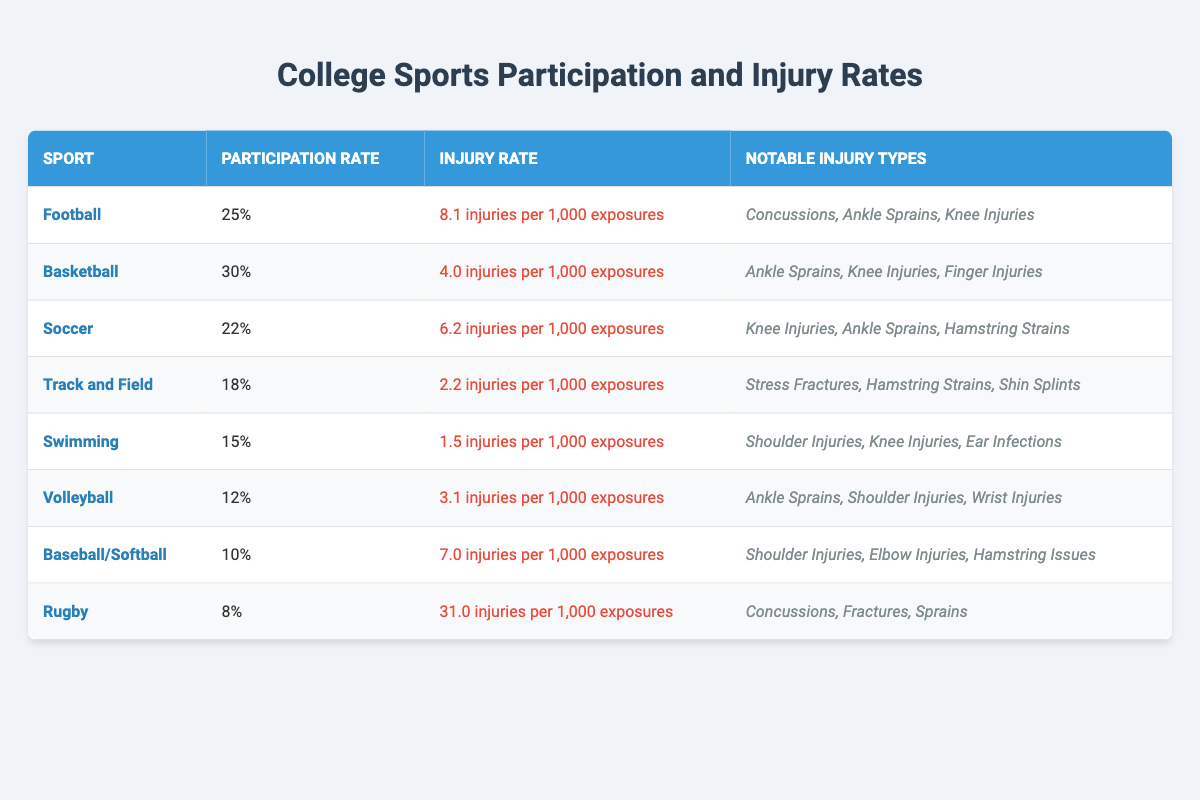What is the participation rate for Soccer? The table lists the participation rate for Soccer as 22%.
Answer: 22% Which sport has the highest injury rate? Rugby has the highest injury rate at 31.0 injuries per 1,000 exposures.
Answer: Rugby How many notable injury types are listed for Volleyball? The table shows that Volleyball has three notable injury types: Ankle Sprains, Shoulder Injuries, and Wrist Injuries.
Answer: 3 What is the injury rate for Swimming compared to Track and Field? Swimming has an injury rate of 1.5 injuries per 1,000 exposures, while Track and Field has a higher rate of 2.2 injuries per 1,000 exposures. Therefore, Swimming's injury rate is lower than Track and Field's.
Answer: Lower If we sum the participation rates of all sports listed, what is the total percentage? The participation rates are 25%, 30%, 22%, 18%, 15%, 12%, 10%, and 8%. Adding these gives: 25 + 30 + 22 + 18 + 15 + 12 + 10 + 8 = 140%.
Answer: 140% What is the difference in injury rates between Football and Basketball? Football has an injury rate of 8.1 injuries per 1,000 exposures and Basketball has 4.0 injuries per 1,000 exposures. The difference is 8.1 - 4.0 = 4.1 injuries per 1,000 exposures.
Answer: 4.1 Is it true that the notable injury types for Baseball/Softball include Concussions? Checking the table, Baseball/Softball lists notable injury types as Shoulder Injuries, Elbow Injuries, and Hamstring Issues; Concussions are not among these.
Answer: No Which sport has a participation rate lower than 15%? The sports with participation rates lower than 15% are Volleyball (12%) and Baseball/Softball (10%).
Answer: Volleyball and Baseball/Softball What is the average injury rate across all sports listed in the table? The injury rates per 1,000 exposures are: 8.1, 4.0, 6.2, 2.2, 1.5, 3.1, 7.0, and 31.0. Summing these rates gives 63.1, and dividing by 8 (the number of sports) gives an average of 63.1/8 = 7.8875 injuries per 1,000 exposures.
Answer: 7.89 